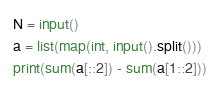<code> <loc_0><loc_0><loc_500><loc_500><_Python_>N = input()
a = list(map(int, input().split()))
print(sum(a[::2]) - sum(a[1::2]))</code> 